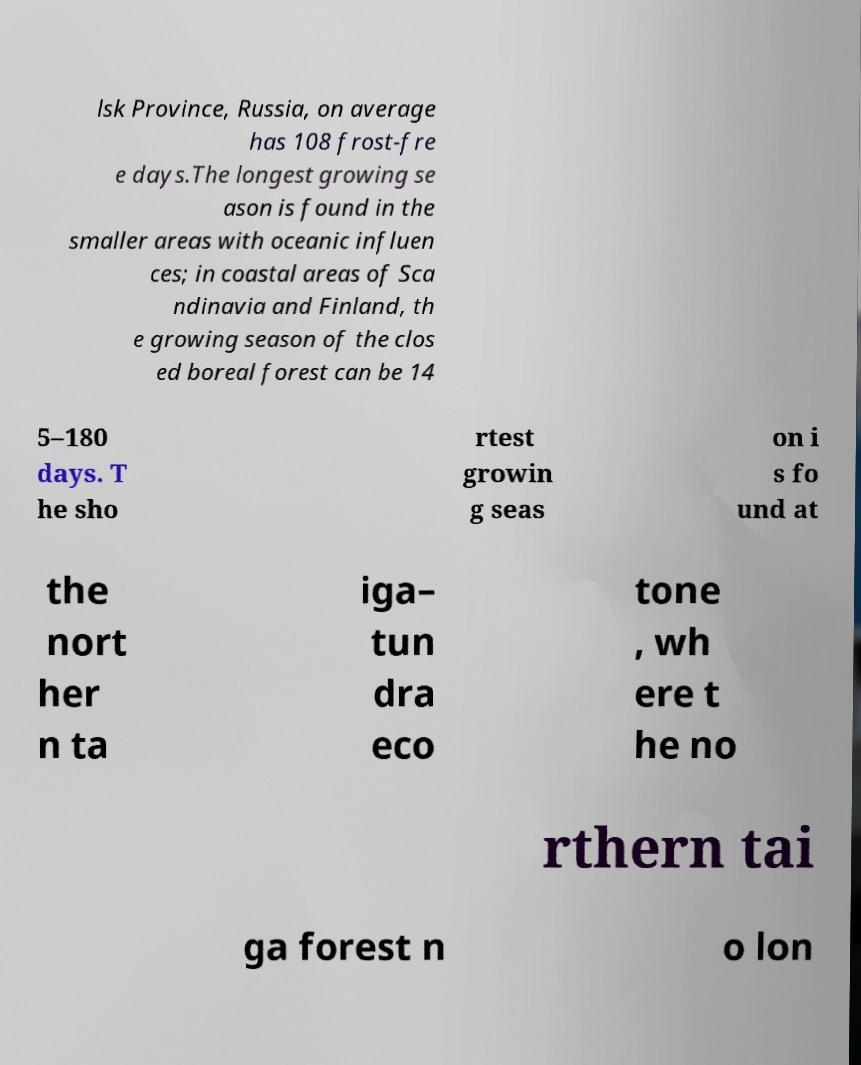I need the written content from this picture converted into text. Can you do that? lsk Province, Russia, on average has 108 frost-fre e days.The longest growing se ason is found in the smaller areas with oceanic influen ces; in coastal areas of Sca ndinavia and Finland, th e growing season of the clos ed boreal forest can be 14 5–180 days. T he sho rtest growin g seas on i s fo und at the nort her n ta iga– tun dra eco tone , wh ere t he no rthern tai ga forest n o lon 